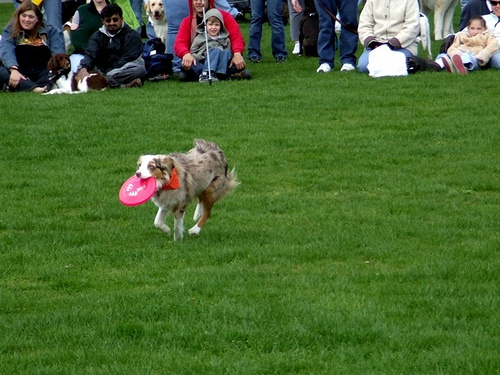Describe the objects in this image and their specific colors. I can see dog in gray, darkgray, and olive tones, people in gray, black, and blue tones, people in gray, black, and darkgray tones, people in gray, lightgray, and darkgray tones, and people in gray, black, and brown tones in this image. 